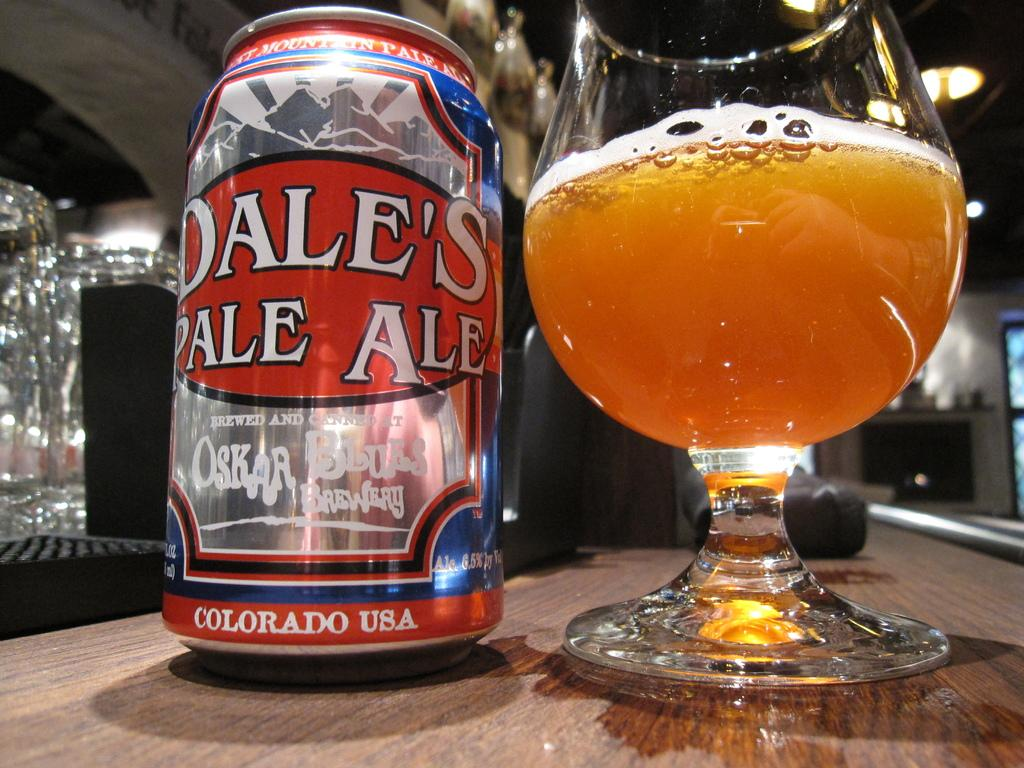<image>
Present a compact description of the photo's key features. A glass of beer next to a can of beer brewed in Colorado. 